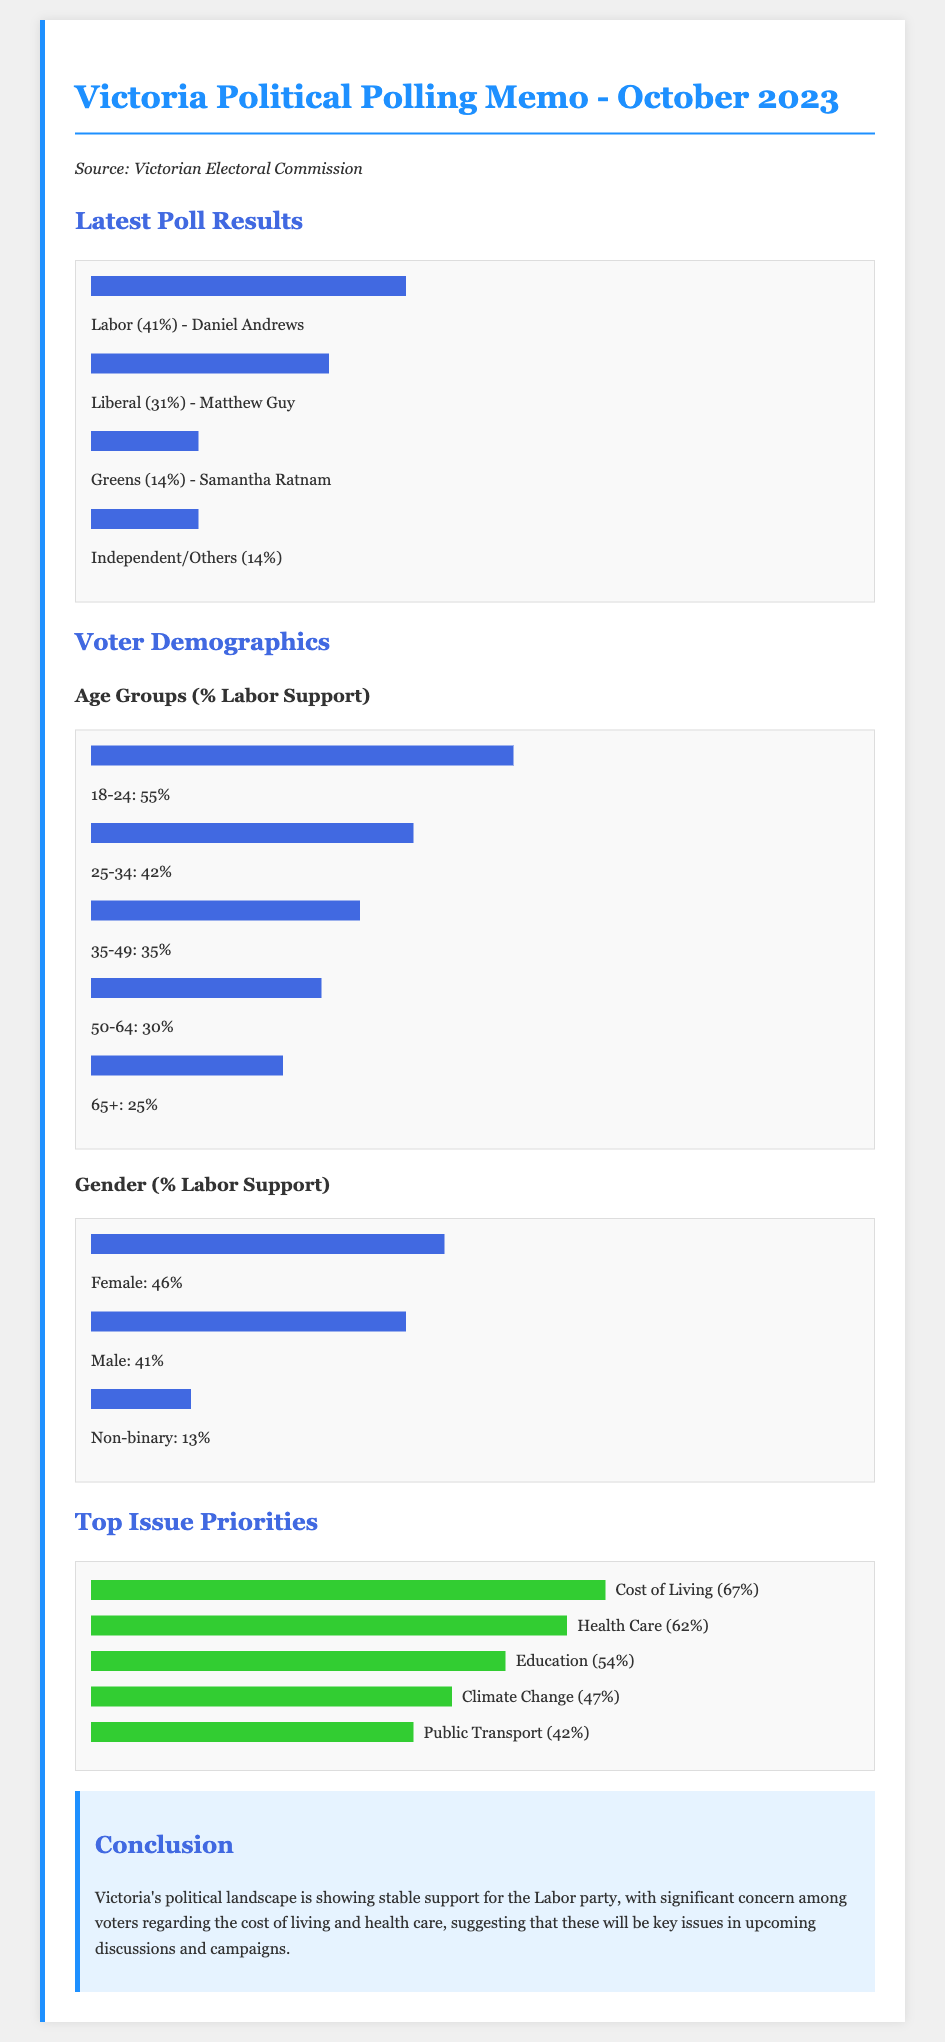What is the current percentage of support for the Labor party? The current percentage of support for the Labor party is stated in the polling results section of the document.
Answer: 41% Who is the leader of the Liberal party? The document identifies the leader of the Liberal party in the latest poll results section.
Answer: Matthew Guy What percentage of female voters support the Labor party? The document shows the percentage of female voters supporting the Labor party under voter demographics.
Answer: 46% What is the top issue priority among voters? The document details the top issue priorities, with the highest percentage mentioned first.
Answer: Cost of Living What percentage of 18-24 year-olds support the Labor party? The percentage of Labor support among the 18-24 age group is detailed under voter demographics.
Answer: 55% Which issue has a lower priority than education but higher than public transport? The document provides a ranking of issue priorities which can be compared to determine their relative importance.
Answer: Climate Change What color is used to highlight the conclusion section in the memo? The color usage for various sections is specified in the document, with a particular mention of the conclusion section.
Answer: Light blue What is the point percentage of support for the Greens? The document includes a specific percentage for the Greens in the poll results section.
Answer: 14% 